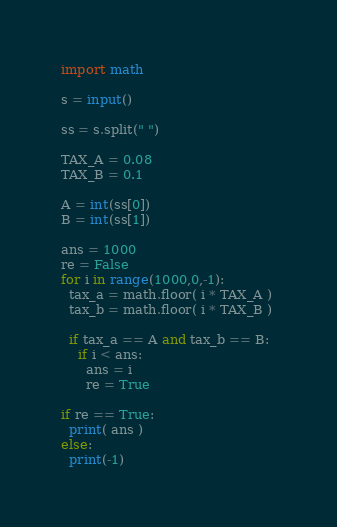<code> <loc_0><loc_0><loc_500><loc_500><_Python_>import math

s = input()

ss = s.split(" ")

TAX_A = 0.08
TAX_B = 0.1

A = int(ss[0])
B = int(ss[1])

ans = 1000
re = False
for i in range(1000,0,-1):
  tax_a = math.floor( i * TAX_A ) 
  tax_b = math.floor( i * TAX_B )

  if tax_a == A and tax_b == B:
    if i < ans:
      ans = i
      re = True

if re == True:
  print( ans )
else:
  print(-1)

</code> 